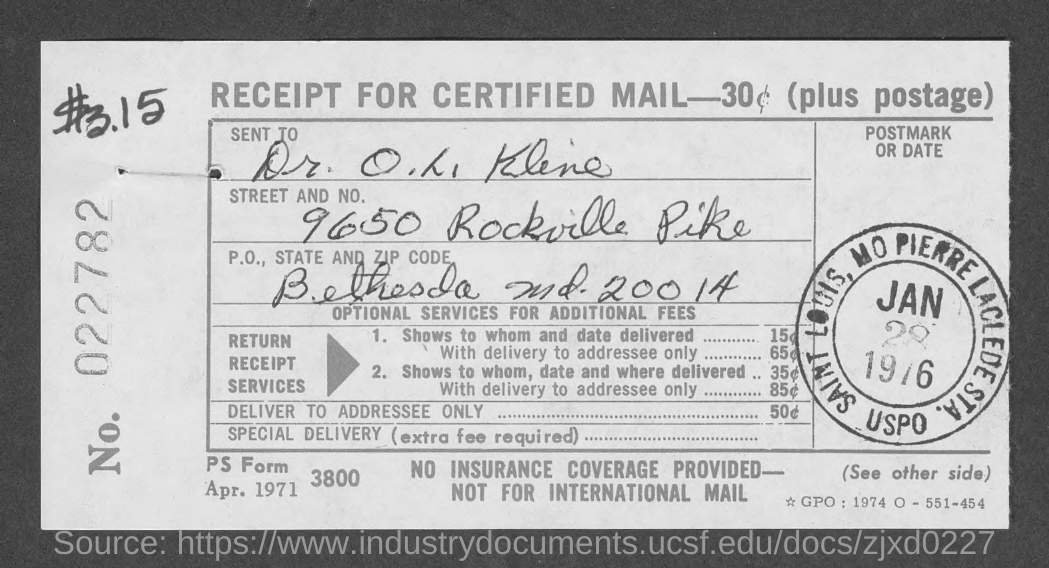Indicate a few pertinent items in this graphic. The mail is sent to Dr. O. L. Kline. I have received a receipt with a P.O. (postal) address of "What is the P.O., State and Zip code given in the receipt? Bethesda md. 20014." in it. The P.O. address is located in Bethesda, Maryland, and the Zip code is 20014. 